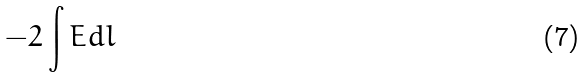<formula> <loc_0><loc_0><loc_500><loc_500>- 2 \int E d l</formula> 